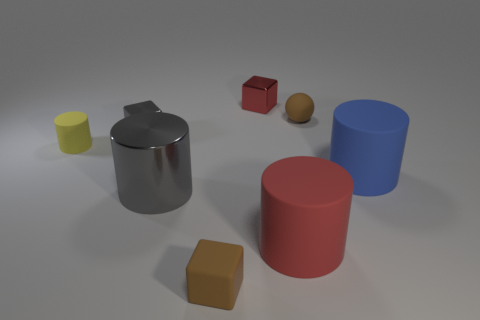Is the shape of the red metallic object the same as the blue thing? No, the shapes are different. The red metallic object has a cylindrical body with a flat top and a spout, indicating it is likely a kettle. The blue object is also cylindrical but with a completely flat top, resembling a simple cylinder with no additional features. 